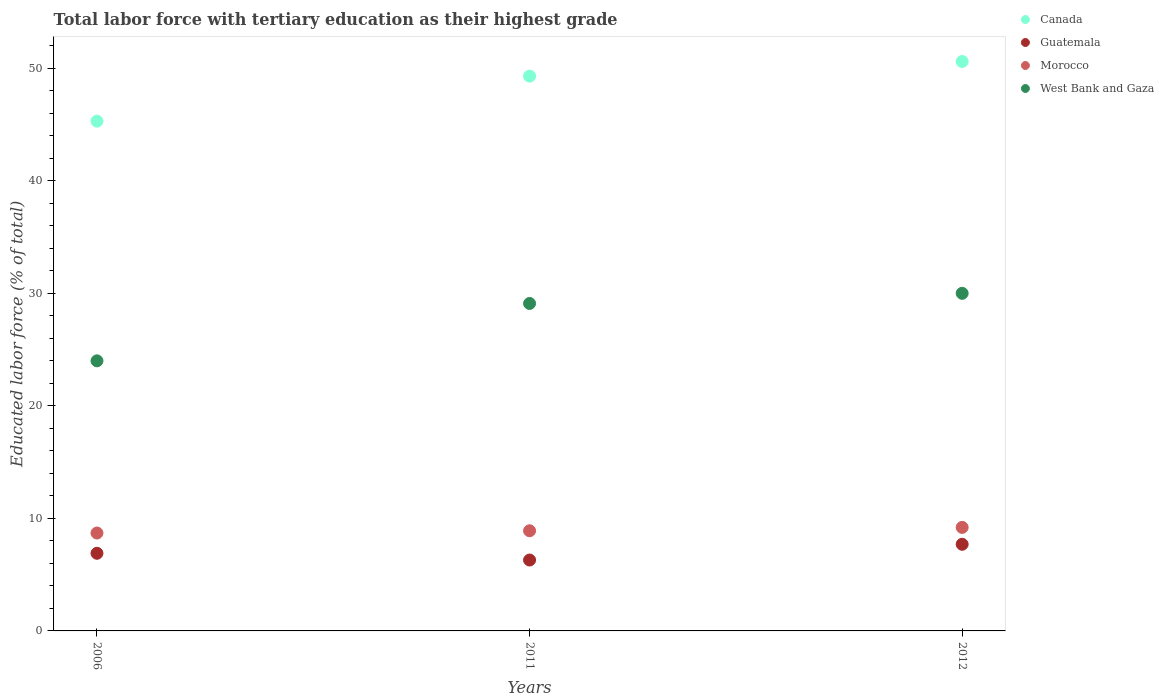How many different coloured dotlines are there?
Keep it short and to the point. 4. Across all years, what is the maximum percentage of male labor force with tertiary education in Guatemala?
Make the answer very short. 7.7. In which year was the percentage of male labor force with tertiary education in Guatemala maximum?
Your response must be concise. 2012. In which year was the percentage of male labor force with tertiary education in Canada minimum?
Give a very brief answer. 2006. What is the total percentage of male labor force with tertiary education in West Bank and Gaza in the graph?
Your answer should be compact. 83.1. What is the difference between the percentage of male labor force with tertiary education in Morocco in 2011 and that in 2012?
Offer a terse response. -0.3. What is the difference between the percentage of male labor force with tertiary education in West Bank and Gaza in 2006 and the percentage of male labor force with tertiary education in Guatemala in 2012?
Make the answer very short. 16.3. What is the average percentage of male labor force with tertiary education in Guatemala per year?
Your answer should be compact. 6.97. In the year 2011, what is the difference between the percentage of male labor force with tertiary education in Morocco and percentage of male labor force with tertiary education in West Bank and Gaza?
Your answer should be very brief. -20.2. In how many years, is the percentage of male labor force with tertiary education in Guatemala greater than 24 %?
Give a very brief answer. 0. What is the ratio of the percentage of male labor force with tertiary education in Guatemala in 2006 to that in 2011?
Make the answer very short. 1.1. Is the percentage of male labor force with tertiary education in Morocco in 2006 less than that in 2011?
Offer a terse response. Yes. Is the difference between the percentage of male labor force with tertiary education in Morocco in 2006 and 2011 greater than the difference between the percentage of male labor force with tertiary education in West Bank and Gaza in 2006 and 2011?
Ensure brevity in your answer.  Yes. What is the difference between the highest and the second highest percentage of male labor force with tertiary education in Canada?
Ensure brevity in your answer.  1.3. What is the difference between the highest and the lowest percentage of male labor force with tertiary education in Guatemala?
Your response must be concise. 1.4. Is the sum of the percentage of male labor force with tertiary education in Canada in 2011 and 2012 greater than the maximum percentage of male labor force with tertiary education in Guatemala across all years?
Make the answer very short. Yes. Is it the case that in every year, the sum of the percentage of male labor force with tertiary education in Canada and percentage of male labor force with tertiary education in Guatemala  is greater than the sum of percentage of male labor force with tertiary education in West Bank and Gaza and percentage of male labor force with tertiary education in Morocco?
Your answer should be compact. No. Is it the case that in every year, the sum of the percentage of male labor force with tertiary education in Morocco and percentage of male labor force with tertiary education in Canada  is greater than the percentage of male labor force with tertiary education in Guatemala?
Keep it short and to the point. Yes. How many dotlines are there?
Provide a short and direct response. 4. Does the graph contain grids?
Provide a short and direct response. No. How many legend labels are there?
Make the answer very short. 4. How are the legend labels stacked?
Provide a succinct answer. Vertical. What is the title of the graph?
Give a very brief answer. Total labor force with tertiary education as their highest grade. Does "Kyrgyz Republic" appear as one of the legend labels in the graph?
Keep it short and to the point. No. What is the label or title of the Y-axis?
Your response must be concise. Educated labor force (% of total). What is the Educated labor force (% of total) of Canada in 2006?
Ensure brevity in your answer.  45.3. What is the Educated labor force (% of total) of Guatemala in 2006?
Ensure brevity in your answer.  6.9. What is the Educated labor force (% of total) in Morocco in 2006?
Keep it short and to the point. 8.7. What is the Educated labor force (% of total) of West Bank and Gaza in 2006?
Your answer should be very brief. 24. What is the Educated labor force (% of total) in Canada in 2011?
Ensure brevity in your answer.  49.3. What is the Educated labor force (% of total) in Guatemala in 2011?
Offer a terse response. 6.3. What is the Educated labor force (% of total) of Morocco in 2011?
Your response must be concise. 8.9. What is the Educated labor force (% of total) of West Bank and Gaza in 2011?
Your answer should be very brief. 29.1. What is the Educated labor force (% of total) of Canada in 2012?
Ensure brevity in your answer.  50.6. What is the Educated labor force (% of total) in Guatemala in 2012?
Your response must be concise. 7.7. What is the Educated labor force (% of total) in Morocco in 2012?
Give a very brief answer. 9.2. What is the Educated labor force (% of total) in West Bank and Gaza in 2012?
Ensure brevity in your answer.  30. Across all years, what is the maximum Educated labor force (% of total) in Canada?
Provide a succinct answer. 50.6. Across all years, what is the maximum Educated labor force (% of total) in Guatemala?
Provide a succinct answer. 7.7. Across all years, what is the maximum Educated labor force (% of total) in Morocco?
Offer a very short reply. 9.2. Across all years, what is the maximum Educated labor force (% of total) in West Bank and Gaza?
Provide a succinct answer. 30. Across all years, what is the minimum Educated labor force (% of total) of Canada?
Give a very brief answer. 45.3. Across all years, what is the minimum Educated labor force (% of total) in Guatemala?
Make the answer very short. 6.3. Across all years, what is the minimum Educated labor force (% of total) in Morocco?
Your answer should be compact. 8.7. Across all years, what is the minimum Educated labor force (% of total) of West Bank and Gaza?
Ensure brevity in your answer.  24. What is the total Educated labor force (% of total) in Canada in the graph?
Your answer should be compact. 145.2. What is the total Educated labor force (% of total) of Guatemala in the graph?
Make the answer very short. 20.9. What is the total Educated labor force (% of total) in Morocco in the graph?
Ensure brevity in your answer.  26.8. What is the total Educated labor force (% of total) in West Bank and Gaza in the graph?
Give a very brief answer. 83.1. What is the difference between the Educated labor force (% of total) in Canada in 2006 and that in 2011?
Give a very brief answer. -4. What is the difference between the Educated labor force (% of total) in Guatemala in 2006 and that in 2011?
Make the answer very short. 0.6. What is the difference between the Educated labor force (% of total) of Morocco in 2006 and that in 2011?
Make the answer very short. -0.2. What is the difference between the Educated labor force (% of total) in West Bank and Gaza in 2006 and that in 2011?
Your answer should be very brief. -5.1. What is the difference between the Educated labor force (% of total) of Morocco in 2006 and that in 2012?
Give a very brief answer. -0.5. What is the difference between the Educated labor force (% of total) in West Bank and Gaza in 2006 and that in 2012?
Keep it short and to the point. -6. What is the difference between the Educated labor force (% of total) in Morocco in 2011 and that in 2012?
Provide a short and direct response. -0.3. What is the difference between the Educated labor force (% of total) of Canada in 2006 and the Educated labor force (% of total) of Guatemala in 2011?
Your answer should be very brief. 39. What is the difference between the Educated labor force (% of total) of Canada in 2006 and the Educated labor force (% of total) of Morocco in 2011?
Offer a very short reply. 36.4. What is the difference between the Educated labor force (% of total) of Guatemala in 2006 and the Educated labor force (% of total) of West Bank and Gaza in 2011?
Provide a short and direct response. -22.2. What is the difference between the Educated labor force (% of total) in Morocco in 2006 and the Educated labor force (% of total) in West Bank and Gaza in 2011?
Provide a succinct answer. -20.4. What is the difference between the Educated labor force (% of total) in Canada in 2006 and the Educated labor force (% of total) in Guatemala in 2012?
Provide a short and direct response. 37.6. What is the difference between the Educated labor force (% of total) of Canada in 2006 and the Educated labor force (% of total) of Morocco in 2012?
Your answer should be very brief. 36.1. What is the difference between the Educated labor force (% of total) of Guatemala in 2006 and the Educated labor force (% of total) of West Bank and Gaza in 2012?
Ensure brevity in your answer.  -23.1. What is the difference between the Educated labor force (% of total) in Morocco in 2006 and the Educated labor force (% of total) in West Bank and Gaza in 2012?
Give a very brief answer. -21.3. What is the difference between the Educated labor force (% of total) of Canada in 2011 and the Educated labor force (% of total) of Guatemala in 2012?
Ensure brevity in your answer.  41.6. What is the difference between the Educated labor force (% of total) of Canada in 2011 and the Educated labor force (% of total) of Morocco in 2012?
Provide a succinct answer. 40.1. What is the difference between the Educated labor force (% of total) of Canada in 2011 and the Educated labor force (% of total) of West Bank and Gaza in 2012?
Ensure brevity in your answer.  19.3. What is the difference between the Educated labor force (% of total) in Guatemala in 2011 and the Educated labor force (% of total) in West Bank and Gaza in 2012?
Offer a very short reply. -23.7. What is the difference between the Educated labor force (% of total) of Morocco in 2011 and the Educated labor force (% of total) of West Bank and Gaza in 2012?
Provide a short and direct response. -21.1. What is the average Educated labor force (% of total) of Canada per year?
Provide a succinct answer. 48.4. What is the average Educated labor force (% of total) in Guatemala per year?
Keep it short and to the point. 6.97. What is the average Educated labor force (% of total) in Morocco per year?
Your answer should be very brief. 8.93. What is the average Educated labor force (% of total) of West Bank and Gaza per year?
Offer a very short reply. 27.7. In the year 2006, what is the difference between the Educated labor force (% of total) of Canada and Educated labor force (% of total) of Guatemala?
Your response must be concise. 38.4. In the year 2006, what is the difference between the Educated labor force (% of total) of Canada and Educated labor force (% of total) of Morocco?
Offer a terse response. 36.6. In the year 2006, what is the difference between the Educated labor force (% of total) of Canada and Educated labor force (% of total) of West Bank and Gaza?
Provide a short and direct response. 21.3. In the year 2006, what is the difference between the Educated labor force (% of total) in Guatemala and Educated labor force (% of total) in Morocco?
Provide a short and direct response. -1.8. In the year 2006, what is the difference between the Educated labor force (% of total) of Guatemala and Educated labor force (% of total) of West Bank and Gaza?
Make the answer very short. -17.1. In the year 2006, what is the difference between the Educated labor force (% of total) of Morocco and Educated labor force (% of total) of West Bank and Gaza?
Offer a very short reply. -15.3. In the year 2011, what is the difference between the Educated labor force (% of total) in Canada and Educated labor force (% of total) in Guatemala?
Keep it short and to the point. 43. In the year 2011, what is the difference between the Educated labor force (% of total) of Canada and Educated labor force (% of total) of Morocco?
Offer a terse response. 40.4. In the year 2011, what is the difference between the Educated labor force (% of total) of Canada and Educated labor force (% of total) of West Bank and Gaza?
Your answer should be compact. 20.2. In the year 2011, what is the difference between the Educated labor force (% of total) of Guatemala and Educated labor force (% of total) of West Bank and Gaza?
Ensure brevity in your answer.  -22.8. In the year 2011, what is the difference between the Educated labor force (% of total) in Morocco and Educated labor force (% of total) in West Bank and Gaza?
Your answer should be very brief. -20.2. In the year 2012, what is the difference between the Educated labor force (% of total) in Canada and Educated labor force (% of total) in Guatemala?
Ensure brevity in your answer.  42.9. In the year 2012, what is the difference between the Educated labor force (% of total) in Canada and Educated labor force (% of total) in Morocco?
Your response must be concise. 41.4. In the year 2012, what is the difference between the Educated labor force (% of total) in Canada and Educated labor force (% of total) in West Bank and Gaza?
Your answer should be compact. 20.6. In the year 2012, what is the difference between the Educated labor force (% of total) in Guatemala and Educated labor force (% of total) in West Bank and Gaza?
Make the answer very short. -22.3. In the year 2012, what is the difference between the Educated labor force (% of total) in Morocco and Educated labor force (% of total) in West Bank and Gaza?
Your answer should be compact. -20.8. What is the ratio of the Educated labor force (% of total) of Canada in 2006 to that in 2011?
Provide a short and direct response. 0.92. What is the ratio of the Educated labor force (% of total) in Guatemala in 2006 to that in 2011?
Give a very brief answer. 1.1. What is the ratio of the Educated labor force (% of total) in Morocco in 2006 to that in 2011?
Give a very brief answer. 0.98. What is the ratio of the Educated labor force (% of total) of West Bank and Gaza in 2006 to that in 2011?
Keep it short and to the point. 0.82. What is the ratio of the Educated labor force (% of total) of Canada in 2006 to that in 2012?
Ensure brevity in your answer.  0.9. What is the ratio of the Educated labor force (% of total) of Guatemala in 2006 to that in 2012?
Keep it short and to the point. 0.9. What is the ratio of the Educated labor force (% of total) in Morocco in 2006 to that in 2012?
Provide a succinct answer. 0.95. What is the ratio of the Educated labor force (% of total) of West Bank and Gaza in 2006 to that in 2012?
Provide a succinct answer. 0.8. What is the ratio of the Educated labor force (% of total) of Canada in 2011 to that in 2012?
Give a very brief answer. 0.97. What is the ratio of the Educated labor force (% of total) of Guatemala in 2011 to that in 2012?
Give a very brief answer. 0.82. What is the ratio of the Educated labor force (% of total) of Morocco in 2011 to that in 2012?
Give a very brief answer. 0.97. What is the ratio of the Educated labor force (% of total) of West Bank and Gaza in 2011 to that in 2012?
Provide a succinct answer. 0.97. What is the difference between the highest and the second highest Educated labor force (% of total) of Canada?
Offer a very short reply. 1.3. What is the difference between the highest and the lowest Educated labor force (% of total) in Canada?
Offer a very short reply. 5.3. What is the difference between the highest and the lowest Educated labor force (% of total) of Guatemala?
Your answer should be compact. 1.4. What is the difference between the highest and the lowest Educated labor force (% of total) of Morocco?
Your answer should be very brief. 0.5. 